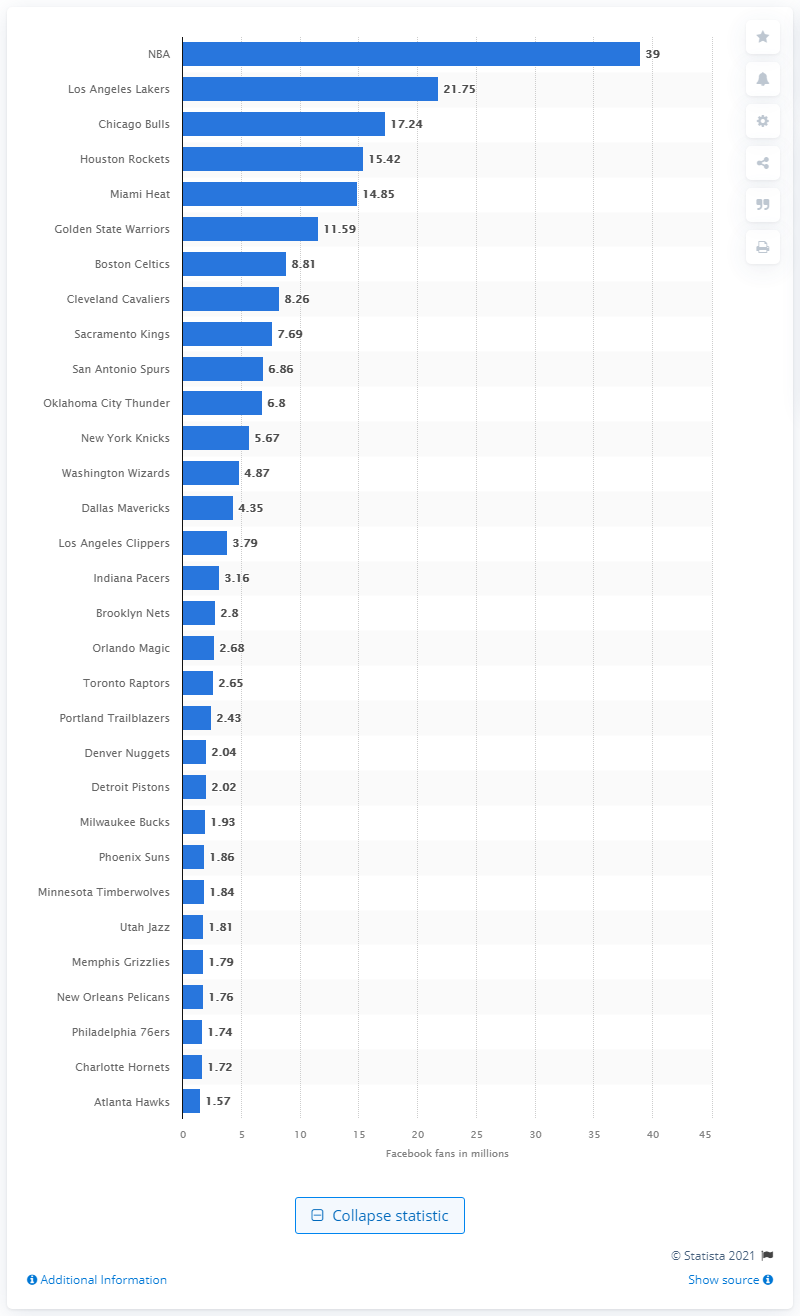Highlight a few significant elements in this photo. The National Basketball Association has 39 million fans on Facebook. The Atlanta Hawks have 1.57 million fans on Facebook. According to the data, the Los Angeles Lakers have 21,750 fans on Facebook. 